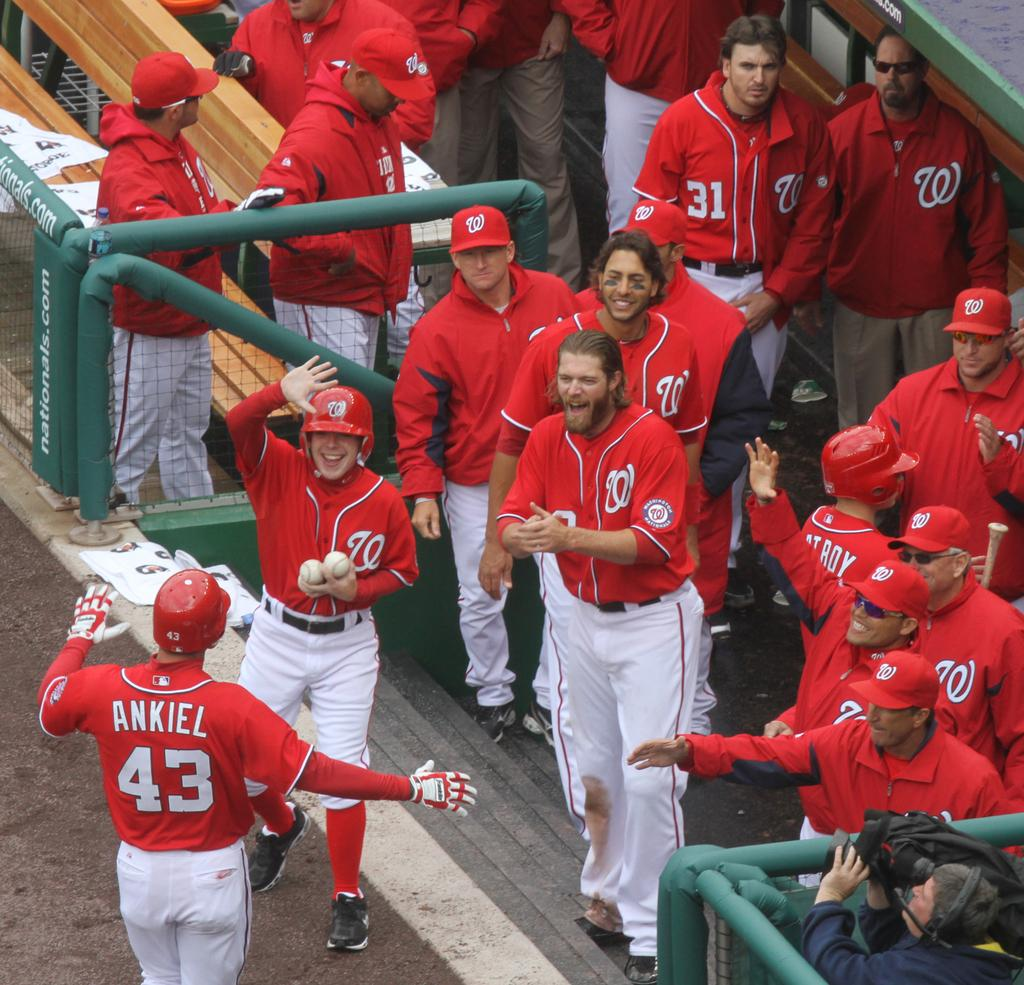<image>
Summarize the visual content of the image. A baseball player Ankiel heads to the dug out where his teammates are cheering on. 